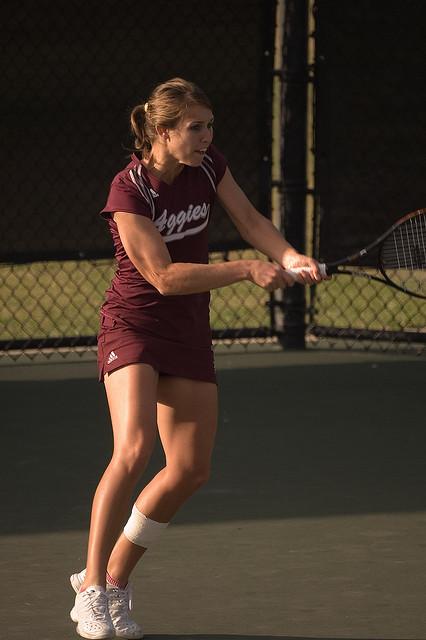What color is her racquet?
Write a very short answer. Black. What is she doing?
Short answer required. Tennis. What is this person holding?
Be succinct. Tennis racket. What color are the girl's shorts?
Write a very short answer. Maroon. What sport is this?
Quick response, please. Tennis. What is kind of bottoms is the woman wearing?
Quick response, please. Shorts. What color is her outfit?
Give a very brief answer. Red. 